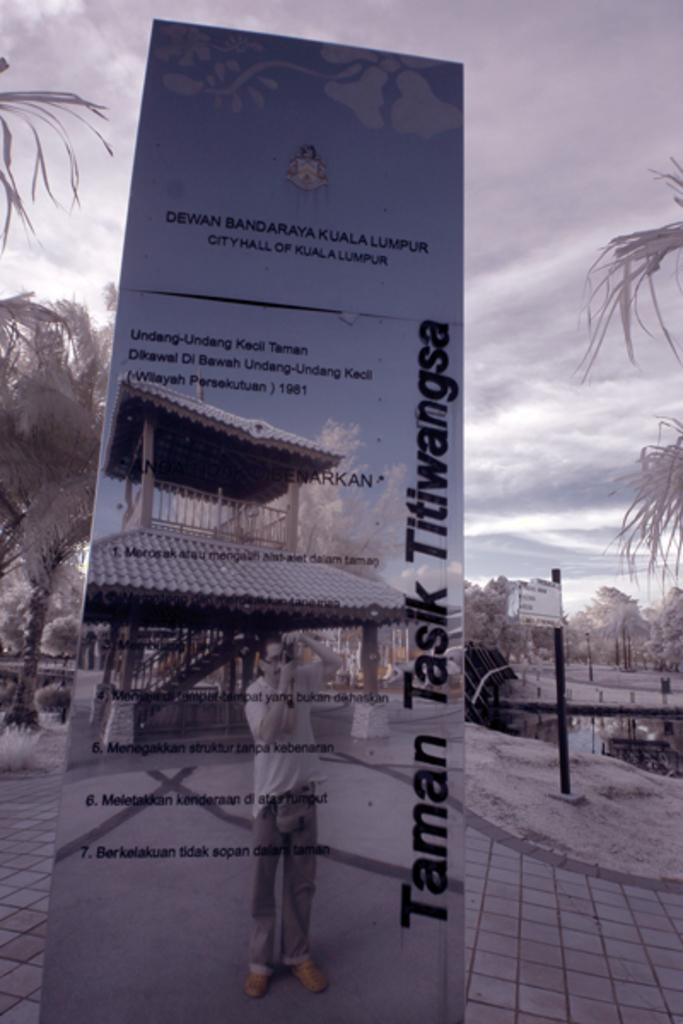What is featured on the poster in the picture? The poster in the picture has text and images. What can be seen on the ground in the image? The ground is visible in the image. What type of vegetation is present in the image? There are trees in the image. What is visible in the image besides the ground and trees? Water and poles are visible in the image. What is visible in the background of the image? The sky is visible in the image, and clouds are present in the sky. What type of pump is visible in the image? There is no pump present in the image. How does the temper of the clouds affect the image? The image does not depict the temper of the clouds, as it is a static representation. 